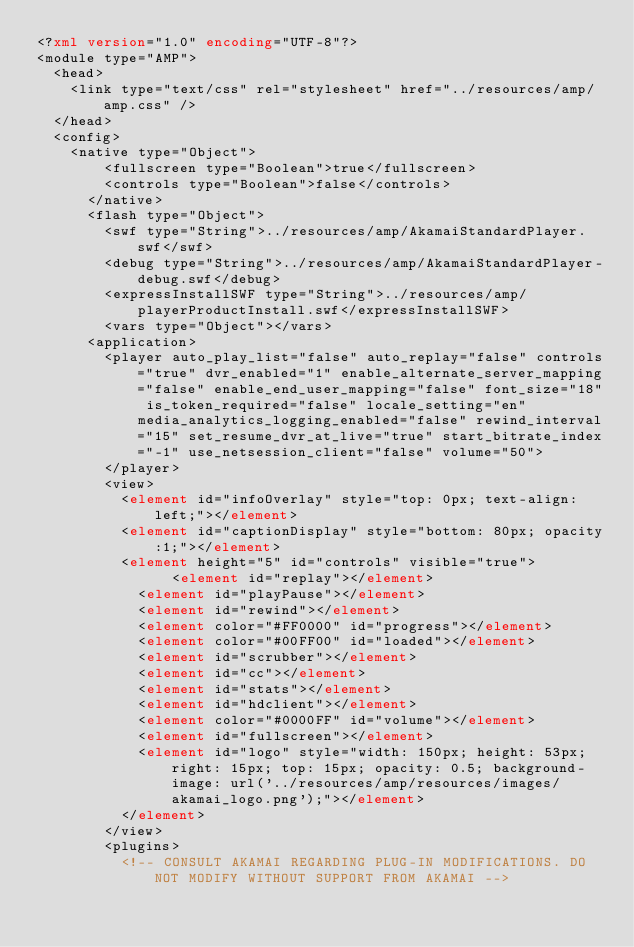<code> <loc_0><loc_0><loc_500><loc_500><_XML_><?xml version="1.0" encoding="UTF-8"?>
<module type="AMP">
	<head>
		<link type="text/css" rel="stylesheet" href="../resources/amp/amp.css" />
	</head>
	<config>
		<native type="Object">
	    	<fullscreen type="Boolean">true</fullscreen>
	    	<controls type="Boolean">false</controls>
	   	</native>
	   	<flash type="Object">
	   		<swf type="String">../resources/amp/AkamaiStandardPlayer.swf</swf>
	   		<debug type="String">../resources/amp/AkamaiStandardPlayer-debug.swf</debug>
	   		<expressInstallSWF type="String">../resources/amp/playerProductInstall.swf</expressInstallSWF>
	   		<vars type="Object"></vars>
			<application>
				<player auto_play_list="false" auto_replay="false" controls="true" dvr_enabled="1" enable_alternate_server_mapping="false" enable_end_user_mapping="false" font_size="18" is_token_required="false" locale_setting="en" media_analytics_logging_enabled="false" rewind_interval="15" set_resume_dvr_at_live="true" start_bitrate_index="-1" use_netsession_client="false" volume="50">
				</player>
				<view>
					<element id="infoOverlay" style="top: 0px; text-align: left;"></element>
					<element id="captionDisplay" style="bottom: 80px; opacity:1;"></element>
					<element height="5" id="controls" visible="true">
				        <element id="replay"></element>
						<element id="playPause"></element>
						<element id="rewind"></element>
						<element color="#FF0000" id="progress"></element>
						<element color="#00FF00" id="loaded"></element>
						<element id="scrubber"></element>
						<element id="cc"></element>
						<element id="stats"></element>
						<element id="hdclient"></element>
						<element color="#0000FF" id="volume"></element>
						<element id="fullscreen"></element>
						<element id="logo" style="width: 150px; height: 53px; right: 15px; top: 15px; opacity: 0.5; background-image: url('../resources/amp/resources/images/akamai_logo.png');"></element>
					</element>
				</view>
				<plugins>
					<!-- CONSULT AKAMAI REGARDING PLUG-IN MODIFICATIONS. DO NOT MODIFY WITHOUT SUPPORT FROM AKAMAI --></code> 